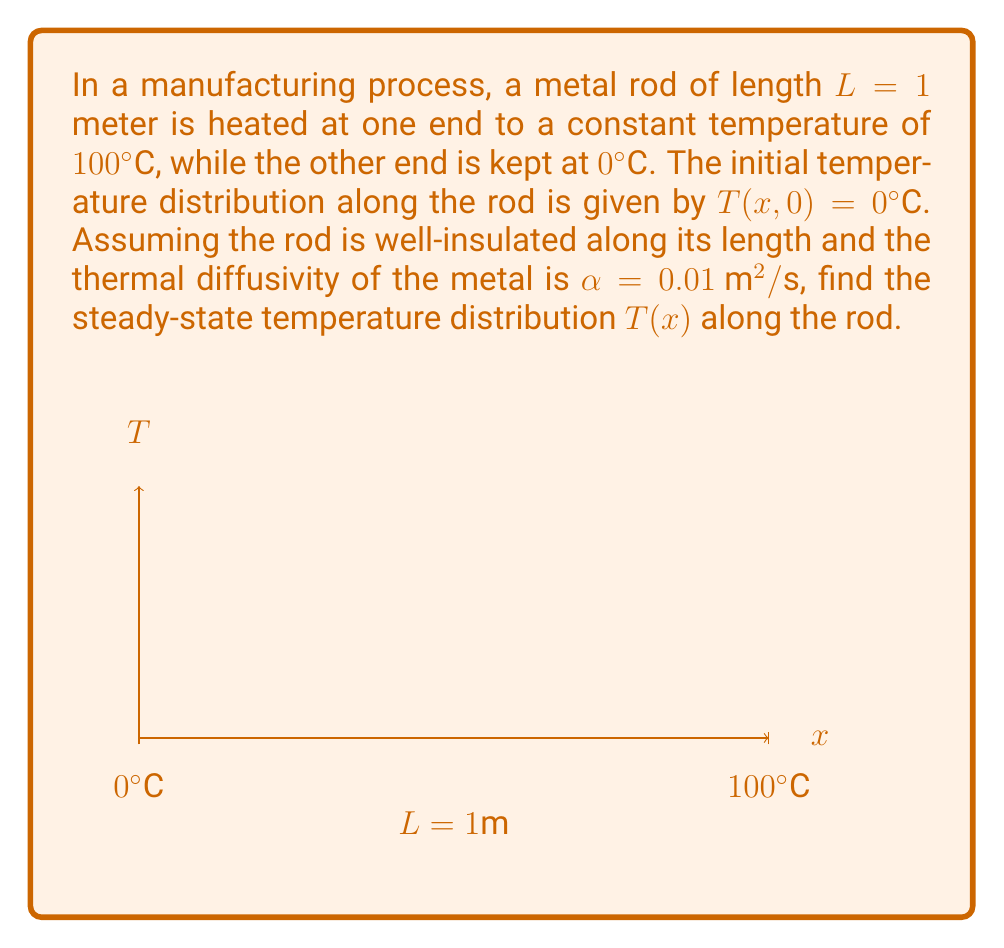Give your solution to this math problem. To solve this problem, we'll use the steady-state heat equation and apply the given boundary conditions:

1) The steady-state heat equation in one dimension is:

   $$\frac{d^2T}{dx^2} = 0$$

2) The general solution to this equation is:

   $$T(x) = Ax + B$$

   where A and B are constants to be determined from the boundary conditions.

3) Apply the boundary conditions:
   At x = 0, T(0) = 0°C
   At x = L = 1m, T(1) = 100°C

4) Substituting these into our general solution:
   T(0) = 0 = A(0) + B, so B = 0
   T(1) = 100 = A(1) + 0, so A = 100

5) Therefore, our steady-state temperature distribution is:

   $$T(x) = 100x$$

This linear distribution shows that the temperature increases steadily from 0°C at x = 0 to 100°C at x = 1m.

Note: The thermal diffusivity α and the initial condition T(x,0) = 0°C are not needed for the steady-state solution, as it's independent of time and initial conditions.
Answer: T(x) = 100x 